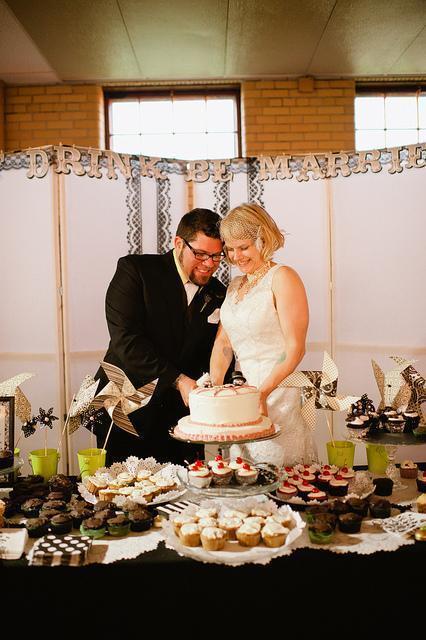What are the two touching?
Choose the correct response and explain in the format: 'Answer: answer
Rationale: rationale.'
Options: Brownies, cake, pie, muffins. Answer: cake.
Rationale: They are cutting a food item at the same time while dressed in bride and groom attire in a room filled with trays of cupcakes. 